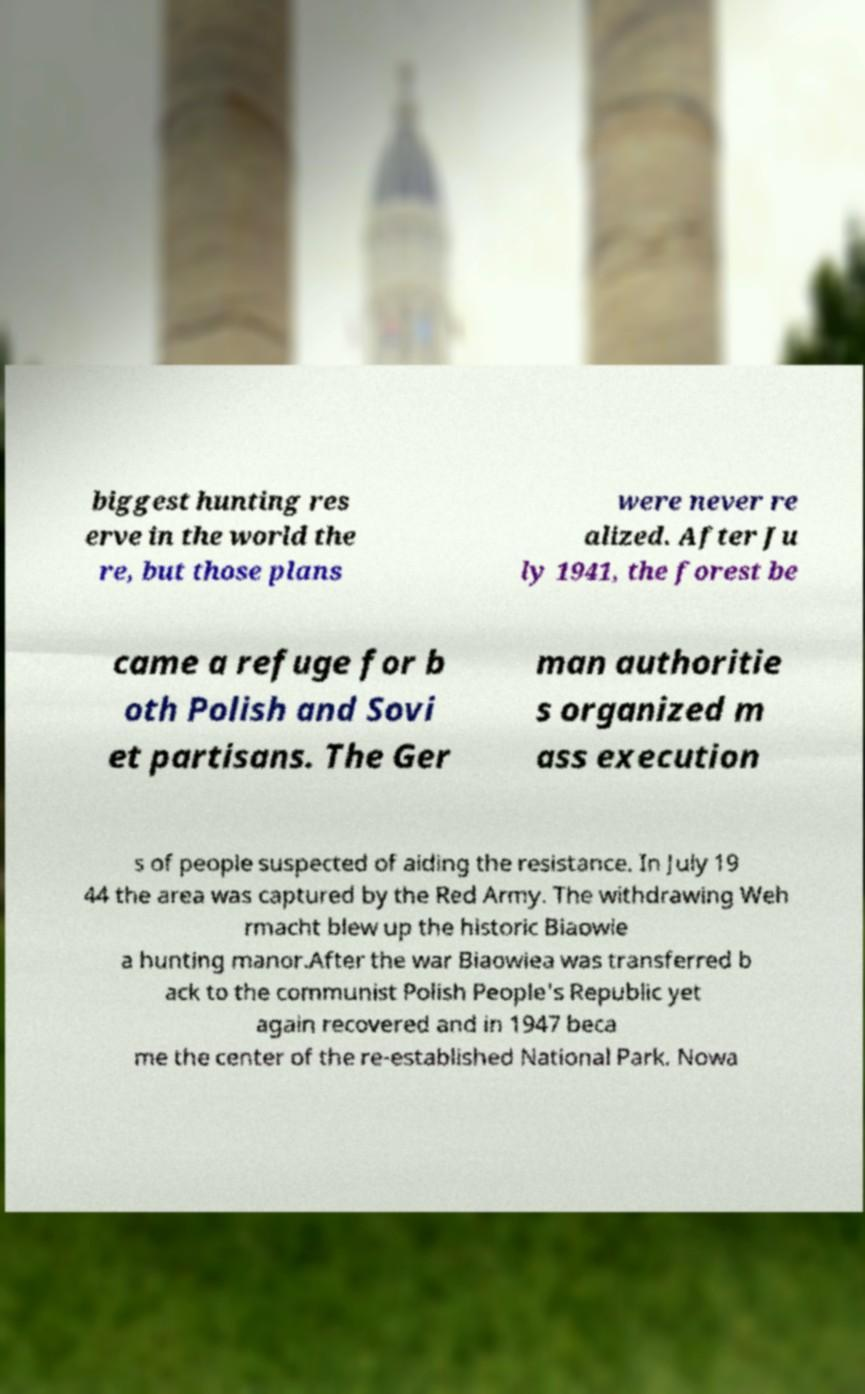Please read and relay the text visible in this image. What does it say? biggest hunting res erve in the world the re, but those plans were never re alized. After Ju ly 1941, the forest be came a refuge for b oth Polish and Sovi et partisans. The Ger man authoritie s organized m ass execution s of people suspected of aiding the resistance. In July 19 44 the area was captured by the Red Army. The withdrawing Weh rmacht blew up the historic Biaowie a hunting manor.After the war Biaowiea was transferred b ack to the communist Polish People's Republic yet again recovered and in 1947 beca me the center of the re-established National Park. Nowa 